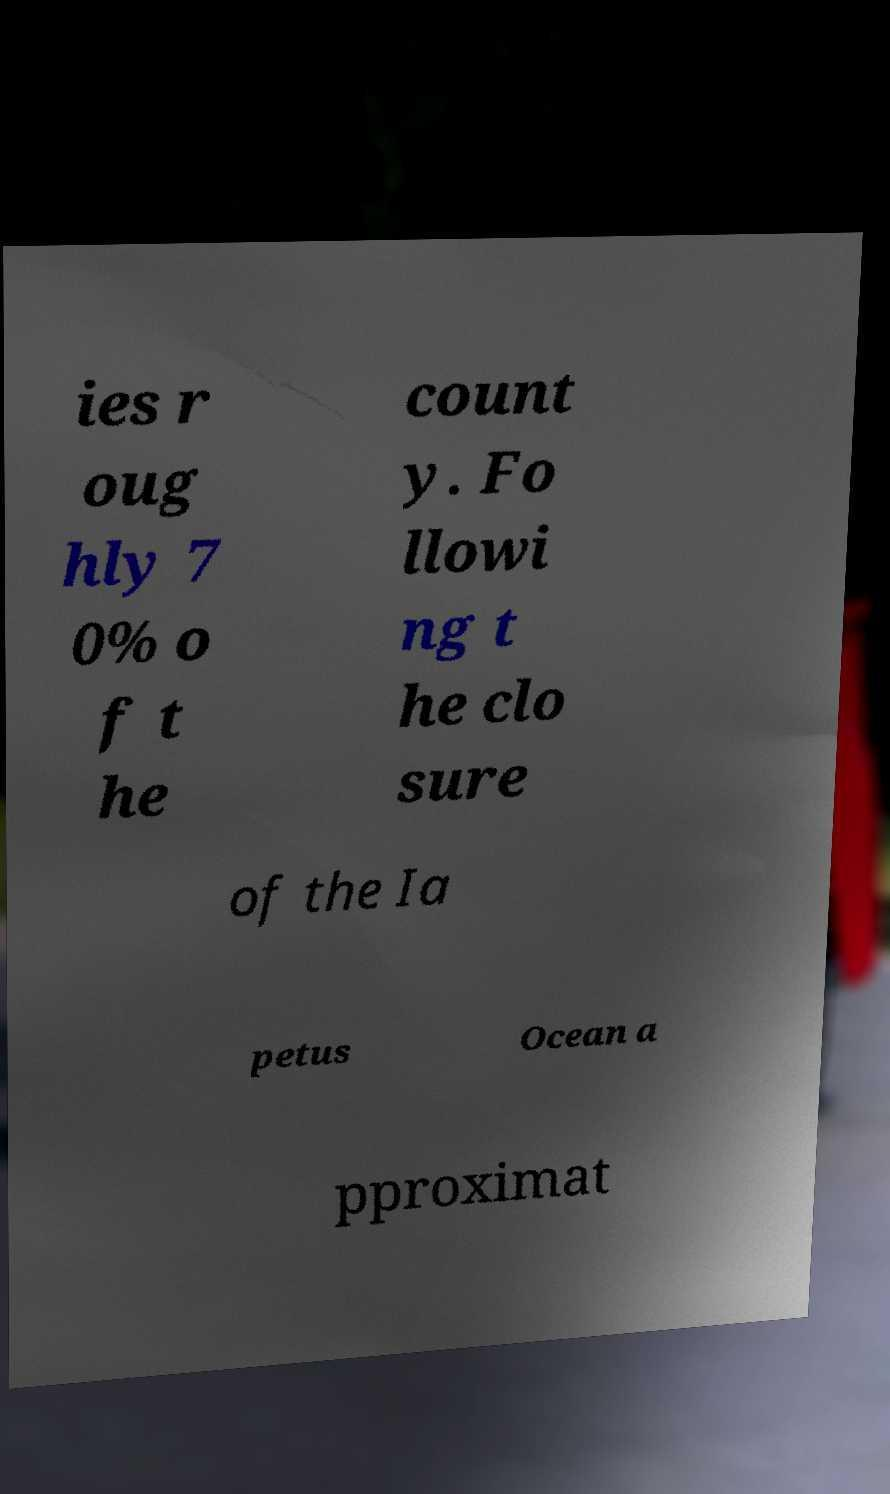Could you extract and type out the text from this image? ies r oug hly 7 0% o f t he count y. Fo llowi ng t he clo sure of the Ia petus Ocean a pproximat 